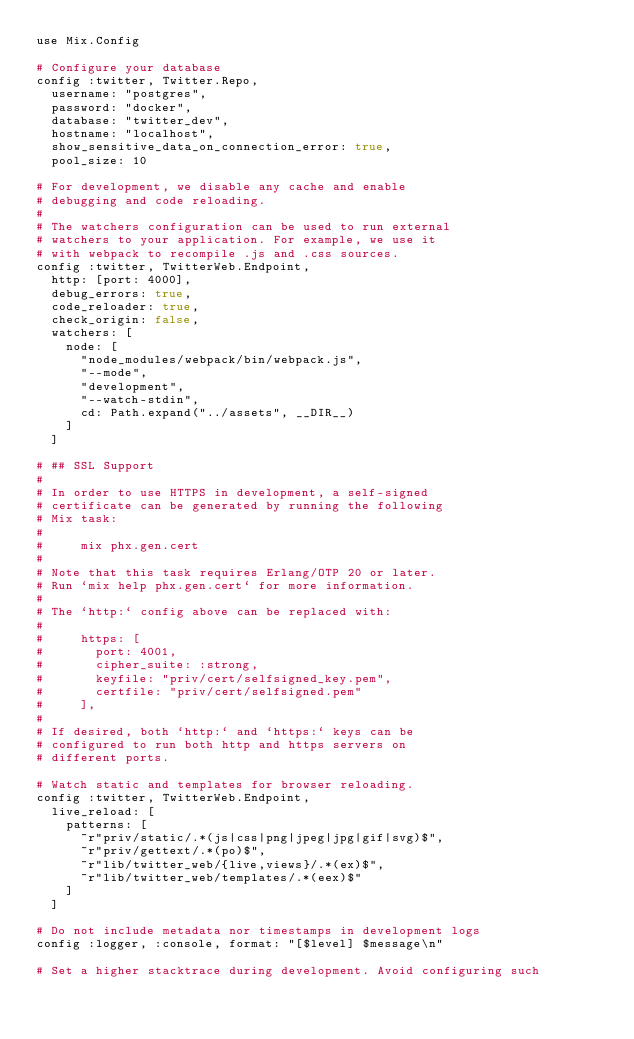Convert code to text. <code><loc_0><loc_0><loc_500><loc_500><_Elixir_>use Mix.Config

# Configure your database
config :twitter, Twitter.Repo,
  username: "postgres",
  password: "docker",
  database: "twitter_dev",
  hostname: "localhost",
  show_sensitive_data_on_connection_error: true,
  pool_size: 10

# For development, we disable any cache and enable
# debugging and code reloading.
#
# The watchers configuration can be used to run external
# watchers to your application. For example, we use it
# with webpack to recompile .js and .css sources.
config :twitter, TwitterWeb.Endpoint,
  http: [port: 4000],
  debug_errors: true,
  code_reloader: true,
  check_origin: false,
  watchers: [
    node: [
      "node_modules/webpack/bin/webpack.js",
      "--mode",
      "development",
      "--watch-stdin",
      cd: Path.expand("../assets", __DIR__)
    ]
  ]

# ## SSL Support
#
# In order to use HTTPS in development, a self-signed
# certificate can be generated by running the following
# Mix task:
#
#     mix phx.gen.cert
#
# Note that this task requires Erlang/OTP 20 or later.
# Run `mix help phx.gen.cert` for more information.
#
# The `http:` config above can be replaced with:
#
#     https: [
#       port: 4001,
#       cipher_suite: :strong,
#       keyfile: "priv/cert/selfsigned_key.pem",
#       certfile: "priv/cert/selfsigned.pem"
#     ],
#
# If desired, both `http:` and `https:` keys can be
# configured to run both http and https servers on
# different ports.

# Watch static and templates for browser reloading.
config :twitter, TwitterWeb.Endpoint,
  live_reload: [
    patterns: [
      ~r"priv/static/.*(js|css|png|jpeg|jpg|gif|svg)$",
      ~r"priv/gettext/.*(po)$",
      ~r"lib/twitter_web/{live,views}/.*(ex)$",
      ~r"lib/twitter_web/templates/.*(eex)$"
    ]
  ]

# Do not include metadata nor timestamps in development logs
config :logger, :console, format: "[$level] $message\n"

# Set a higher stacktrace during development. Avoid configuring such</code> 